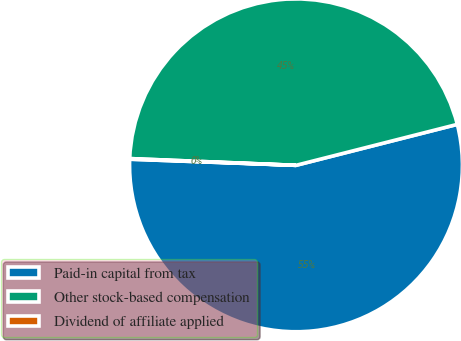<chart> <loc_0><loc_0><loc_500><loc_500><pie_chart><fcel>Paid-in capital from tax<fcel>Other stock-based compensation<fcel>Dividend of affiliate applied<nl><fcel>54.55%<fcel>45.4%<fcel>0.06%<nl></chart> 